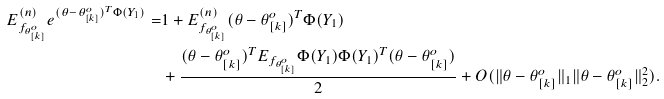Convert formula to latex. <formula><loc_0><loc_0><loc_500><loc_500>E _ { f _ { \theta _ { [ k ] } ^ { o } } } ^ { ( n ) } e ^ { ( \theta - \theta _ { [ k ] } ^ { o } ) ^ { T } \Phi ( Y _ { 1 } ) } = & 1 + E _ { f _ { \theta _ { [ k ] } ^ { o } } } ^ { ( n ) } ( \theta - \theta _ { [ k ] } ^ { o } ) ^ { T } \Phi ( Y _ { 1 } ) \\ & + \frac { ( \theta - \theta _ { [ k ] } ^ { o } ) ^ { T } E _ { f _ { \theta _ { [ k ] } ^ { o } } } \Phi ( Y _ { 1 } ) \Phi ( Y _ { 1 } ) ^ { T } ( \theta - \theta _ { [ k ] } ^ { o } ) } { 2 } + O ( \| \theta - \theta _ { [ k ] } ^ { o } \| _ { 1 } \| \theta - \theta _ { [ k ] } ^ { o } \| _ { 2 } ^ { 2 } ) .</formula> 